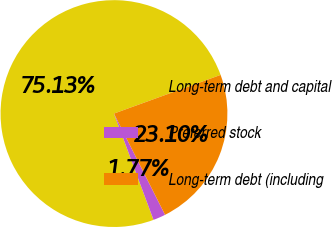Convert chart. <chart><loc_0><loc_0><loc_500><loc_500><pie_chart><fcel>Long-term debt and capital<fcel>Preferred stock<fcel>Long-term debt (including<nl><fcel>75.14%<fcel>1.77%<fcel>23.1%<nl></chart> 